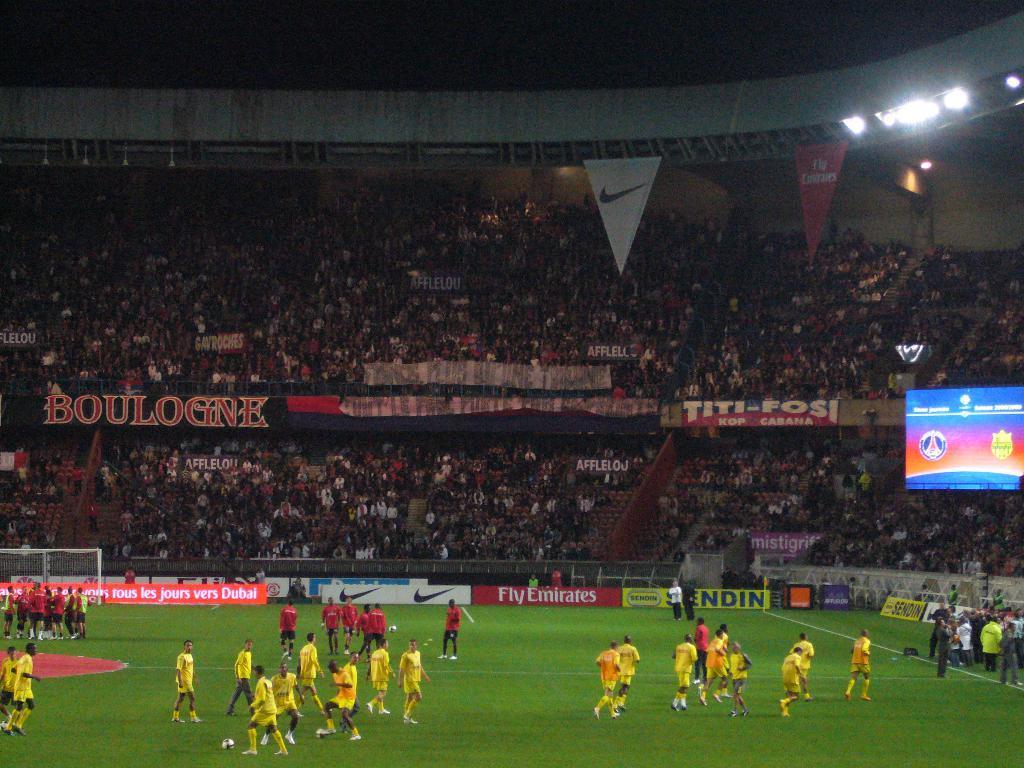How would you summarize this image in a sentence or two? In the picture I can see the sports persons on the ground. There is a goal post on the left side. I can see a few people standing on the side of the ground. In the background, I can see the spectators on the stands. I can see the lighting arrangement on the top right side. I can see a screen on the right side. 